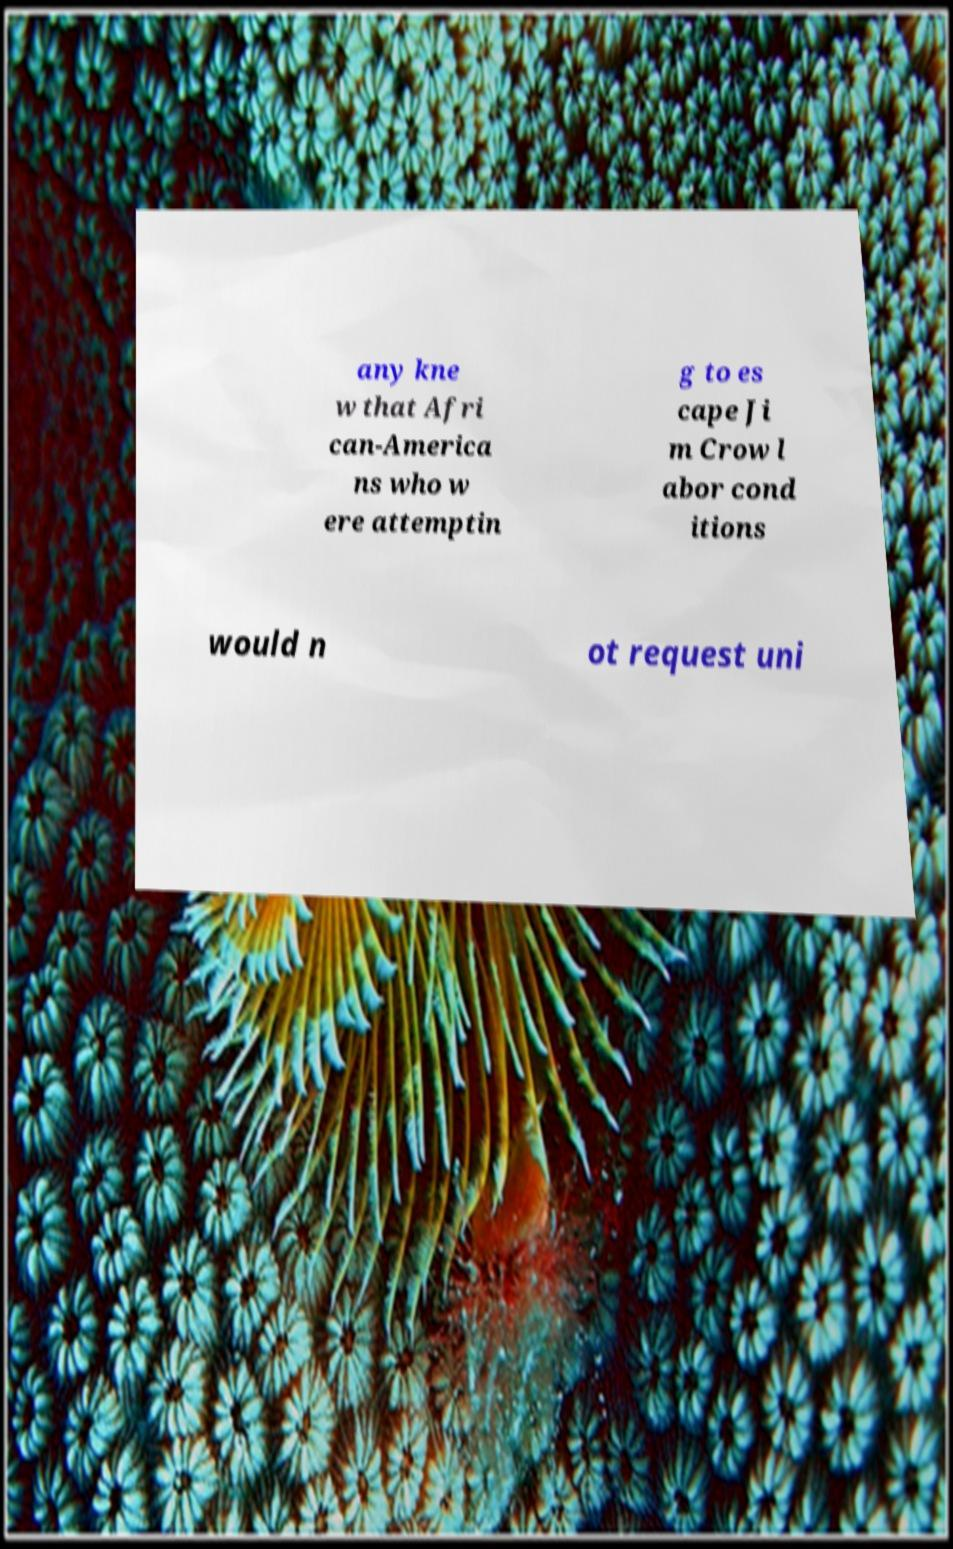What messages or text are displayed in this image? I need them in a readable, typed format. any kne w that Afri can-America ns who w ere attemptin g to es cape Ji m Crow l abor cond itions would n ot request uni 